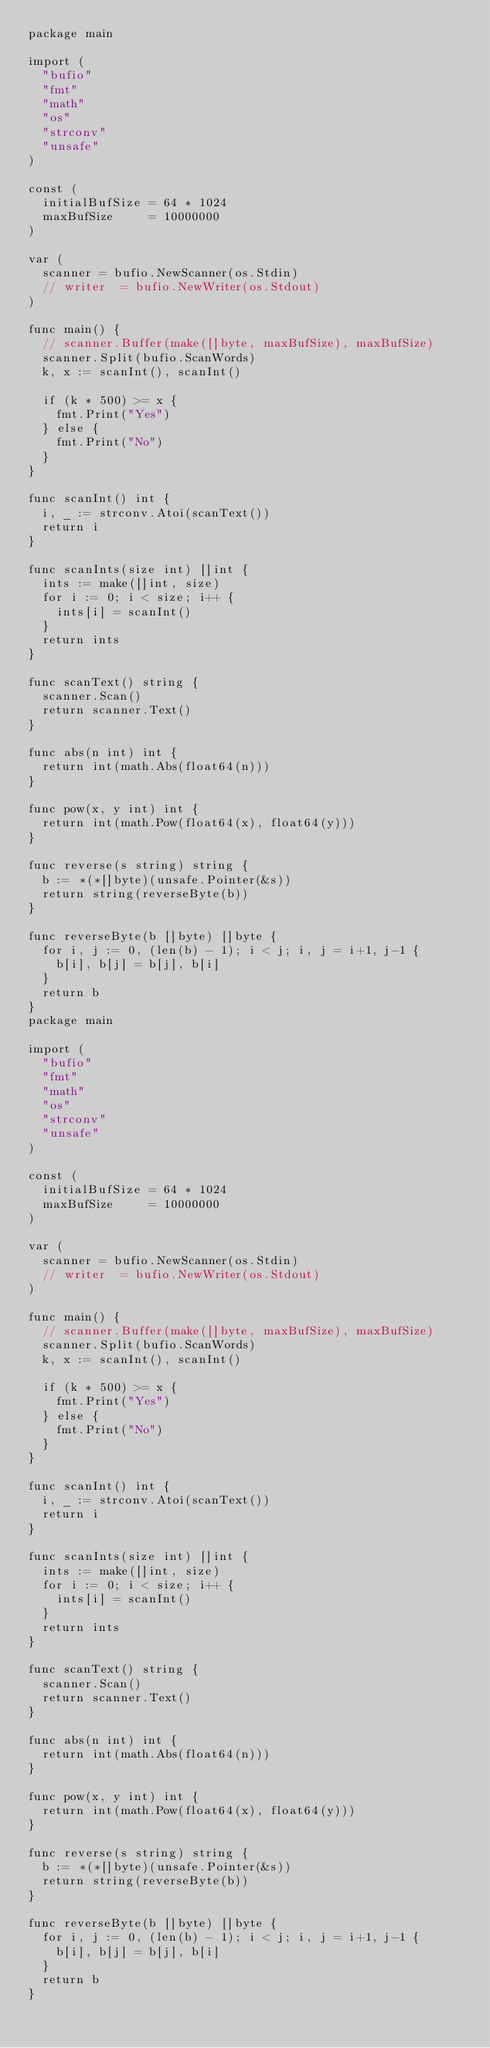<code> <loc_0><loc_0><loc_500><loc_500><_Go_>package main

import (
	"bufio"
	"fmt"
	"math"
	"os"
	"strconv"
	"unsafe"
)

const (
	initialBufSize = 64 * 1024
	maxBufSize     = 10000000
)

var (
	scanner = bufio.NewScanner(os.Stdin)
	// writer  = bufio.NewWriter(os.Stdout)
)

func main() {
	// scanner.Buffer(make([]byte, maxBufSize), maxBufSize)
	scanner.Split(bufio.ScanWords)
	k, x := scanInt(), scanInt()

	if (k * 500) >= x {
		fmt.Print("Yes")
	} else {
		fmt.Print("No")
	}
}

func scanInt() int {
	i, _ := strconv.Atoi(scanText())
	return i
}

func scanInts(size int) []int {
	ints := make([]int, size)
	for i := 0; i < size; i++ {
		ints[i] = scanInt()
	}
	return ints
}

func scanText() string {
	scanner.Scan()
	return scanner.Text()
}

func abs(n int) int {
	return int(math.Abs(float64(n)))
}

func pow(x, y int) int {
	return int(math.Pow(float64(x), float64(y)))
}

func reverse(s string) string {
	b := *(*[]byte)(unsafe.Pointer(&s))
	return string(reverseByte(b))
}

func reverseByte(b []byte) []byte {
	for i, j := 0, (len(b) - 1); i < j; i, j = i+1, j-1 {
		b[i], b[j] = b[j], b[i]
	}
	return b
}
package main

import (
	"bufio"
	"fmt"
	"math"
	"os"
	"strconv"
	"unsafe"
)

const (
	initialBufSize = 64 * 1024
	maxBufSize     = 10000000
)

var (
	scanner = bufio.NewScanner(os.Stdin)
	// writer  = bufio.NewWriter(os.Stdout)
)

func main() {
	// scanner.Buffer(make([]byte, maxBufSize), maxBufSize)
	scanner.Split(bufio.ScanWords)
	k, x := scanInt(), scanInt()

	if (k * 500) >= x {
		fmt.Print("Yes")
	} else {
		fmt.Print("No")
	}
}

func scanInt() int {
	i, _ := strconv.Atoi(scanText())
	return i
}

func scanInts(size int) []int {
	ints := make([]int, size)
	for i := 0; i < size; i++ {
		ints[i] = scanInt()
	}
	return ints
}

func scanText() string {
	scanner.Scan()
	return scanner.Text()
}

func abs(n int) int {
	return int(math.Abs(float64(n)))
}

func pow(x, y int) int {
	return int(math.Pow(float64(x), float64(y)))
}

func reverse(s string) string {
	b := *(*[]byte)(unsafe.Pointer(&s))
	return string(reverseByte(b))
}

func reverseByte(b []byte) []byte {
	for i, j := 0, (len(b) - 1); i < j; i, j = i+1, j-1 {
		b[i], b[j] = b[j], b[i]
	}
	return b
}
</code> 